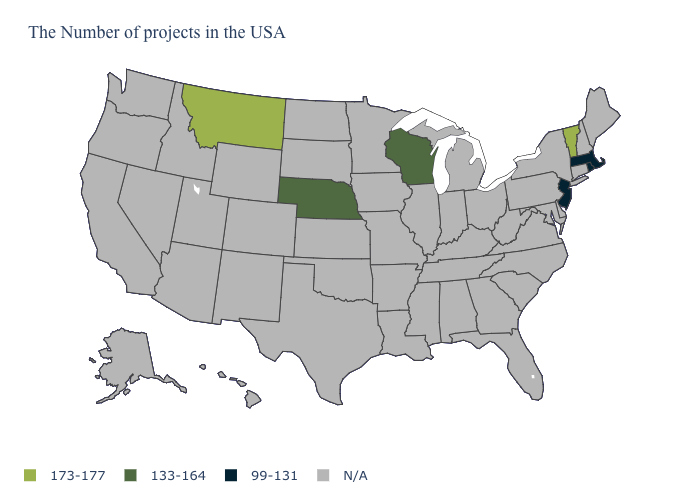Name the states that have a value in the range 133-164?
Be succinct. Wisconsin, Nebraska. What is the highest value in the USA?
Quick response, please. 173-177. Name the states that have a value in the range 99-131?
Short answer required. Massachusetts, Rhode Island, New Jersey. Which states have the lowest value in the USA?
Answer briefly. Massachusetts, Rhode Island, New Jersey. What is the value of New York?
Write a very short answer. N/A. Name the states that have a value in the range 173-177?
Short answer required. Vermont, Montana. Does Vermont have the lowest value in the USA?
Short answer required. No. What is the value of Iowa?
Short answer required. N/A. Name the states that have a value in the range 173-177?
Concise answer only. Vermont, Montana. What is the value of South Dakota?
Answer briefly. N/A. What is the value of Iowa?
Answer briefly. N/A. What is the value of Alabama?
Answer briefly. N/A. 